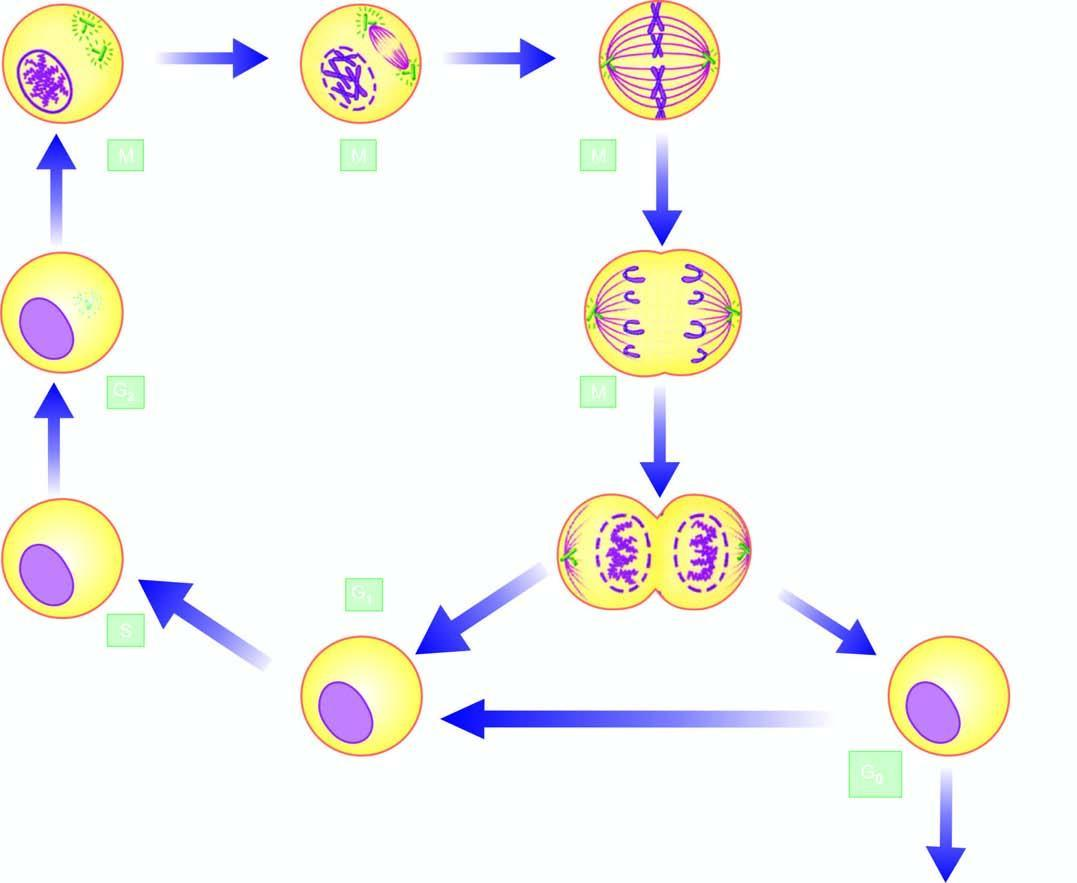re two daughter cells formed which may continue to remain in the cell cycle or go out of it in resting phase interphase, the g0 phase on completion of cell division?
Answer the question using a single word or phrase. Yes 